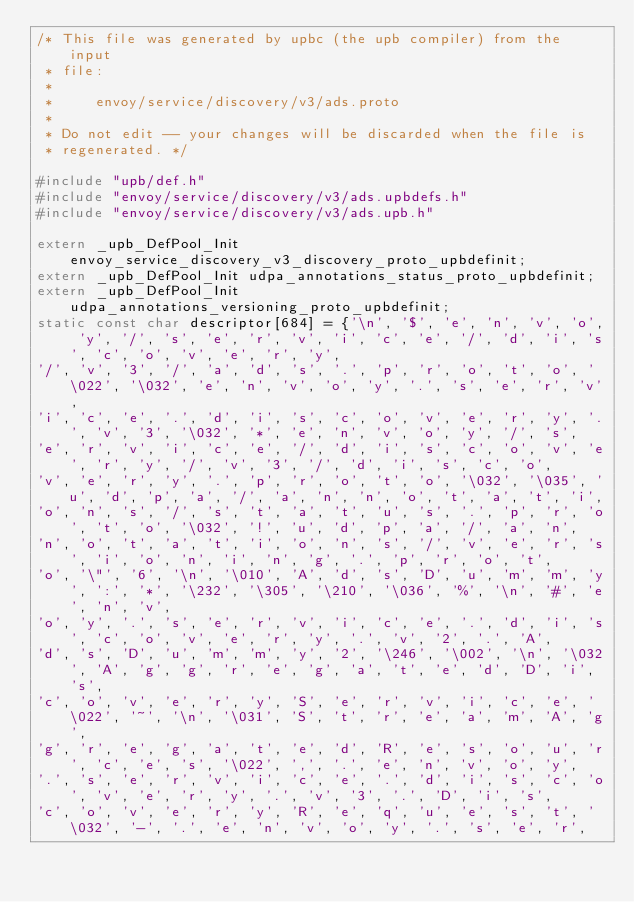<code> <loc_0><loc_0><loc_500><loc_500><_C_>/* This file was generated by upbc (the upb compiler) from the input
 * file:
 *
 *     envoy/service/discovery/v3/ads.proto
 *
 * Do not edit -- your changes will be discarded when the file is
 * regenerated. */

#include "upb/def.h"
#include "envoy/service/discovery/v3/ads.upbdefs.h"
#include "envoy/service/discovery/v3/ads.upb.h"

extern _upb_DefPool_Init envoy_service_discovery_v3_discovery_proto_upbdefinit;
extern _upb_DefPool_Init udpa_annotations_status_proto_upbdefinit;
extern _upb_DefPool_Init udpa_annotations_versioning_proto_upbdefinit;
static const char descriptor[684] = {'\n', '$', 'e', 'n', 'v', 'o', 'y', '/', 's', 'e', 'r', 'v', 'i', 'c', 'e', '/', 'd', 'i', 's', 'c', 'o', 'v', 'e', 'r', 'y', 
'/', 'v', '3', '/', 'a', 'd', 's', '.', 'p', 'r', 'o', 't', 'o', '\022', '\032', 'e', 'n', 'v', 'o', 'y', '.', 's', 'e', 'r', 'v', 
'i', 'c', 'e', '.', 'd', 'i', 's', 'c', 'o', 'v', 'e', 'r', 'y', '.', 'v', '3', '\032', '*', 'e', 'n', 'v', 'o', 'y', '/', 's', 
'e', 'r', 'v', 'i', 'c', 'e', '/', 'd', 'i', 's', 'c', 'o', 'v', 'e', 'r', 'y', '/', 'v', '3', '/', 'd', 'i', 's', 'c', 'o', 
'v', 'e', 'r', 'y', '.', 'p', 'r', 'o', 't', 'o', '\032', '\035', 'u', 'd', 'p', 'a', '/', 'a', 'n', 'n', 'o', 't', 'a', 't', 'i', 
'o', 'n', 's', '/', 's', 't', 'a', 't', 'u', 's', '.', 'p', 'r', 'o', 't', 'o', '\032', '!', 'u', 'd', 'p', 'a', '/', 'a', 'n', 
'n', 'o', 't', 'a', 't', 'i', 'o', 'n', 's', '/', 'v', 'e', 'r', 's', 'i', 'o', 'n', 'i', 'n', 'g', '.', 'p', 'r', 'o', 't', 
'o', '\"', '6', '\n', '\010', 'A', 'd', 's', 'D', 'u', 'm', 'm', 'y', ':', '*', '\232', '\305', '\210', '\036', '%', '\n', '#', 'e', 'n', 'v', 
'o', 'y', '.', 's', 'e', 'r', 'v', 'i', 'c', 'e', '.', 'd', 'i', 's', 'c', 'o', 'v', 'e', 'r', 'y', '.', 'v', '2', '.', 'A', 
'd', 's', 'D', 'u', 'm', 'm', 'y', '2', '\246', '\002', '\n', '\032', 'A', 'g', 'g', 'r', 'e', 'g', 'a', 't', 'e', 'd', 'D', 'i', 's', 
'c', 'o', 'v', 'e', 'r', 'y', 'S', 'e', 'r', 'v', 'i', 'c', 'e', '\022', '~', '\n', '\031', 'S', 't', 'r', 'e', 'a', 'm', 'A', 'g', 
'g', 'r', 'e', 'g', 'a', 't', 'e', 'd', 'R', 'e', 's', 'o', 'u', 'r', 'c', 'e', 's', '\022', ',', '.', 'e', 'n', 'v', 'o', 'y', 
'.', 's', 'e', 'r', 'v', 'i', 'c', 'e', '.', 'd', 'i', 's', 'c', 'o', 'v', 'e', 'r', 'y', '.', 'v', '3', '.', 'D', 'i', 's', 
'c', 'o', 'v', 'e', 'r', 'y', 'R', 'e', 'q', 'u', 'e', 's', 't', '\032', '-', '.', 'e', 'n', 'v', 'o', 'y', '.', 's', 'e', 'r', </code> 